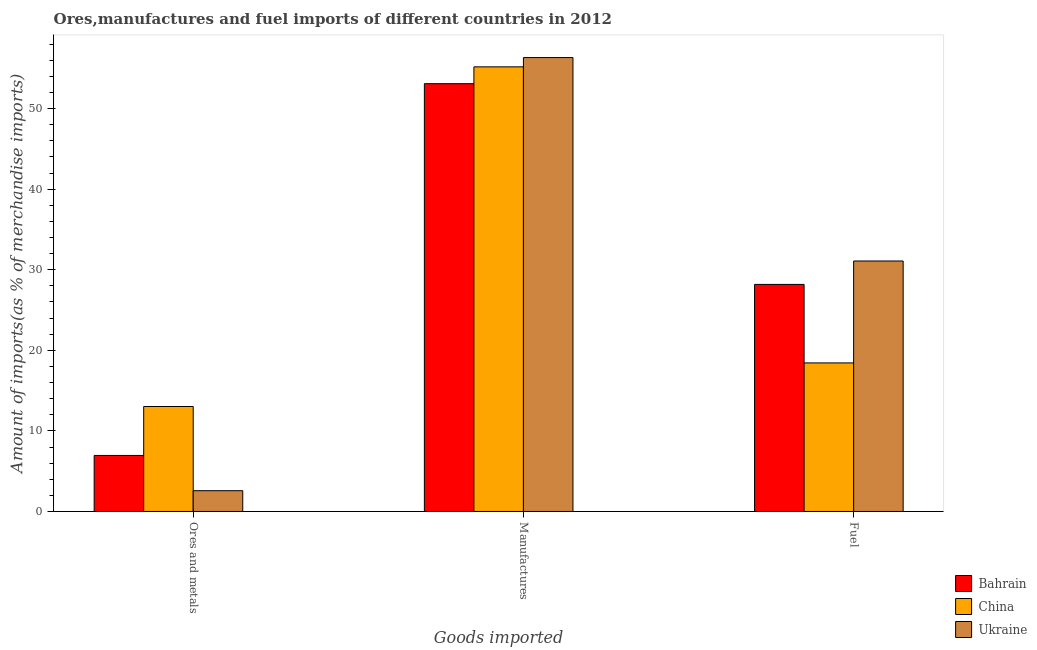How many different coloured bars are there?
Keep it short and to the point. 3. How many groups of bars are there?
Offer a terse response. 3. How many bars are there on the 1st tick from the left?
Your answer should be compact. 3. What is the label of the 2nd group of bars from the left?
Give a very brief answer. Manufactures. What is the percentage of ores and metals imports in Ukraine?
Your answer should be very brief. 2.58. Across all countries, what is the maximum percentage of fuel imports?
Your answer should be compact. 31.08. Across all countries, what is the minimum percentage of manufactures imports?
Provide a succinct answer. 53.09. In which country was the percentage of ores and metals imports maximum?
Your answer should be very brief. China. What is the total percentage of manufactures imports in the graph?
Provide a succinct answer. 164.59. What is the difference between the percentage of manufactures imports in Bahrain and that in China?
Your answer should be compact. -2.09. What is the difference between the percentage of ores and metals imports in China and the percentage of manufactures imports in Ukraine?
Give a very brief answer. -43.3. What is the average percentage of manufactures imports per country?
Your answer should be very brief. 54.86. What is the difference between the percentage of manufactures imports and percentage of fuel imports in Bahrain?
Give a very brief answer. 24.91. What is the ratio of the percentage of fuel imports in Bahrain to that in Ukraine?
Your answer should be very brief. 0.91. What is the difference between the highest and the second highest percentage of ores and metals imports?
Offer a terse response. 6.07. What is the difference between the highest and the lowest percentage of fuel imports?
Ensure brevity in your answer.  12.65. In how many countries, is the percentage of fuel imports greater than the average percentage of fuel imports taken over all countries?
Ensure brevity in your answer.  2. What does the 3rd bar from the left in Ores and metals represents?
Your response must be concise. Ukraine. How many countries are there in the graph?
Your answer should be compact. 3. Where does the legend appear in the graph?
Make the answer very short. Bottom right. How many legend labels are there?
Make the answer very short. 3. What is the title of the graph?
Offer a very short reply. Ores,manufactures and fuel imports of different countries in 2012. Does "Barbados" appear as one of the legend labels in the graph?
Make the answer very short. No. What is the label or title of the X-axis?
Your answer should be compact. Goods imported. What is the label or title of the Y-axis?
Keep it short and to the point. Amount of imports(as % of merchandise imports). What is the Amount of imports(as % of merchandise imports) of Bahrain in Ores and metals?
Provide a succinct answer. 6.95. What is the Amount of imports(as % of merchandise imports) in China in Ores and metals?
Provide a short and direct response. 13.03. What is the Amount of imports(as % of merchandise imports) of Ukraine in Ores and metals?
Give a very brief answer. 2.58. What is the Amount of imports(as % of merchandise imports) of Bahrain in Manufactures?
Provide a short and direct response. 53.09. What is the Amount of imports(as % of merchandise imports) of China in Manufactures?
Provide a short and direct response. 55.17. What is the Amount of imports(as % of merchandise imports) of Ukraine in Manufactures?
Your response must be concise. 56.33. What is the Amount of imports(as % of merchandise imports) in Bahrain in Fuel?
Offer a terse response. 28.18. What is the Amount of imports(as % of merchandise imports) in China in Fuel?
Give a very brief answer. 18.44. What is the Amount of imports(as % of merchandise imports) in Ukraine in Fuel?
Your answer should be very brief. 31.08. Across all Goods imported, what is the maximum Amount of imports(as % of merchandise imports) in Bahrain?
Provide a short and direct response. 53.09. Across all Goods imported, what is the maximum Amount of imports(as % of merchandise imports) in China?
Provide a succinct answer. 55.17. Across all Goods imported, what is the maximum Amount of imports(as % of merchandise imports) in Ukraine?
Make the answer very short. 56.33. Across all Goods imported, what is the minimum Amount of imports(as % of merchandise imports) in Bahrain?
Offer a very short reply. 6.95. Across all Goods imported, what is the minimum Amount of imports(as % of merchandise imports) of China?
Ensure brevity in your answer.  13.03. Across all Goods imported, what is the minimum Amount of imports(as % of merchandise imports) of Ukraine?
Keep it short and to the point. 2.58. What is the total Amount of imports(as % of merchandise imports) of Bahrain in the graph?
Offer a very short reply. 88.22. What is the total Amount of imports(as % of merchandise imports) of China in the graph?
Make the answer very short. 86.64. What is the total Amount of imports(as % of merchandise imports) in Ukraine in the graph?
Offer a very short reply. 89.99. What is the difference between the Amount of imports(as % of merchandise imports) of Bahrain in Ores and metals and that in Manufactures?
Keep it short and to the point. -46.13. What is the difference between the Amount of imports(as % of merchandise imports) of China in Ores and metals and that in Manufactures?
Ensure brevity in your answer.  -42.15. What is the difference between the Amount of imports(as % of merchandise imports) of Ukraine in Ores and metals and that in Manufactures?
Keep it short and to the point. -53.75. What is the difference between the Amount of imports(as % of merchandise imports) in Bahrain in Ores and metals and that in Fuel?
Offer a terse response. -21.22. What is the difference between the Amount of imports(as % of merchandise imports) in China in Ores and metals and that in Fuel?
Offer a terse response. -5.41. What is the difference between the Amount of imports(as % of merchandise imports) of Ukraine in Ores and metals and that in Fuel?
Provide a succinct answer. -28.5. What is the difference between the Amount of imports(as % of merchandise imports) of Bahrain in Manufactures and that in Fuel?
Your answer should be very brief. 24.91. What is the difference between the Amount of imports(as % of merchandise imports) in China in Manufactures and that in Fuel?
Your response must be concise. 36.74. What is the difference between the Amount of imports(as % of merchandise imports) of Ukraine in Manufactures and that in Fuel?
Your answer should be very brief. 25.24. What is the difference between the Amount of imports(as % of merchandise imports) in Bahrain in Ores and metals and the Amount of imports(as % of merchandise imports) in China in Manufactures?
Your response must be concise. -48.22. What is the difference between the Amount of imports(as % of merchandise imports) of Bahrain in Ores and metals and the Amount of imports(as % of merchandise imports) of Ukraine in Manufactures?
Offer a terse response. -49.37. What is the difference between the Amount of imports(as % of merchandise imports) of China in Ores and metals and the Amount of imports(as % of merchandise imports) of Ukraine in Manufactures?
Provide a succinct answer. -43.3. What is the difference between the Amount of imports(as % of merchandise imports) in Bahrain in Ores and metals and the Amount of imports(as % of merchandise imports) in China in Fuel?
Give a very brief answer. -11.48. What is the difference between the Amount of imports(as % of merchandise imports) of Bahrain in Ores and metals and the Amount of imports(as % of merchandise imports) of Ukraine in Fuel?
Offer a very short reply. -24.13. What is the difference between the Amount of imports(as % of merchandise imports) of China in Ores and metals and the Amount of imports(as % of merchandise imports) of Ukraine in Fuel?
Keep it short and to the point. -18.06. What is the difference between the Amount of imports(as % of merchandise imports) in Bahrain in Manufactures and the Amount of imports(as % of merchandise imports) in China in Fuel?
Ensure brevity in your answer.  34.65. What is the difference between the Amount of imports(as % of merchandise imports) of Bahrain in Manufactures and the Amount of imports(as % of merchandise imports) of Ukraine in Fuel?
Give a very brief answer. 22. What is the difference between the Amount of imports(as % of merchandise imports) in China in Manufactures and the Amount of imports(as % of merchandise imports) in Ukraine in Fuel?
Ensure brevity in your answer.  24.09. What is the average Amount of imports(as % of merchandise imports) of Bahrain per Goods imported?
Give a very brief answer. 29.41. What is the average Amount of imports(as % of merchandise imports) of China per Goods imported?
Give a very brief answer. 28.88. What is the average Amount of imports(as % of merchandise imports) in Ukraine per Goods imported?
Offer a very short reply. 30. What is the difference between the Amount of imports(as % of merchandise imports) in Bahrain and Amount of imports(as % of merchandise imports) in China in Ores and metals?
Ensure brevity in your answer.  -6.07. What is the difference between the Amount of imports(as % of merchandise imports) of Bahrain and Amount of imports(as % of merchandise imports) of Ukraine in Ores and metals?
Give a very brief answer. 4.37. What is the difference between the Amount of imports(as % of merchandise imports) of China and Amount of imports(as % of merchandise imports) of Ukraine in Ores and metals?
Make the answer very short. 10.45. What is the difference between the Amount of imports(as % of merchandise imports) of Bahrain and Amount of imports(as % of merchandise imports) of China in Manufactures?
Provide a short and direct response. -2.09. What is the difference between the Amount of imports(as % of merchandise imports) in Bahrain and Amount of imports(as % of merchandise imports) in Ukraine in Manufactures?
Your answer should be compact. -3.24. What is the difference between the Amount of imports(as % of merchandise imports) of China and Amount of imports(as % of merchandise imports) of Ukraine in Manufactures?
Ensure brevity in your answer.  -1.15. What is the difference between the Amount of imports(as % of merchandise imports) of Bahrain and Amount of imports(as % of merchandise imports) of China in Fuel?
Your answer should be compact. 9.74. What is the difference between the Amount of imports(as % of merchandise imports) of Bahrain and Amount of imports(as % of merchandise imports) of Ukraine in Fuel?
Make the answer very short. -2.91. What is the difference between the Amount of imports(as % of merchandise imports) in China and Amount of imports(as % of merchandise imports) in Ukraine in Fuel?
Your answer should be very brief. -12.65. What is the ratio of the Amount of imports(as % of merchandise imports) in Bahrain in Ores and metals to that in Manufactures?
Give a very brief answer. 0.13. What is the ratio of the Amount of imports(as % of merchandise imports) of China in Ores and metals to that in Manufactures?
Ensure brevity in your answer.  0.24. What is the ratio of the Amount of imports(as % of merchandise imports) in Ukraine in Ores and metals to that in Manufactures?
Your answer should be very brief. 0.05. What is the ratio of the Amount of imports(as % of merchandise imports) in Bahrain in Ores and metals to that in Fuel?
Ensure brevity in your answer.  0.25. What is the ratio of the Amount of imports(as % of merchandise imports) in China in Ores and metals to that in Fuel?
Your response must be concise. 0.71. What is the ratio of the Amount of imports(as % of merchandise imports) of Ukraine in Ores and metals to that in Fuel?
Offer a very short reply. 0.08. What is the ratio of the Amount of imports(as % of merchandise imports) of Bahrain in Manufactures to that in Fuel?
Provide a short and direct response. 1.88. What is the ratio of the Amount of imports(as % of merchandise imports) of China in Manufactures to that in Fuel?
Offer a terse response. 2.99. What is the ratio of the Amount of imports(as % of merchandise imports) in Ukraine in Manufactures to that in Fuel?
Make the answer very short. 1.81. What is the difference between the highest and the second highest Amount of imports(as % of merchandise imports) in Bahrain?
Offer a terse response. 24.91. What is the difference between the highest and the second highest Amount of imports(as % of merchandise imports) of China?
Ensure brevity in your answer.  36.74. What is the difference between the highest and the second highest Amount of imports(as % of merchandise imports) in Ukraine?
Your answer should be compact. 25.24. What is the difference between the highest and the lowest Amount of imports(as % of merchandise imports) of Bahrain?
Give a very brief answer. 46.13. What is the difference between the highest and the lowest Amount of imports(as % of merchandise imports) in China?
Ensure brevity in your answer.  42.15. What is the difference between the highest and the lowest Amount of imports(as % of merchandise imports) of Ukraine?
Provide a succinct answer. 53.75. 